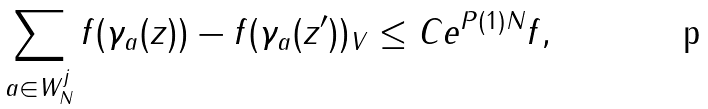Convert formula to latex. <formula><loc_0><loc_0><loc_500><loc_500>\sum _ { a \in W _ { N } ^ { j } } \| f ( \gamma _ { a } ( z ) ) - f ( \gamma _ { a } ( z ^ { \prime } ) ) \| _ { V } \leq C e ^ { P ( 1 ) N } \| f \| ,</formula> 